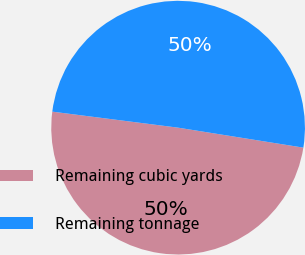Convert chart to OTSL. <chart><loc_0><loc_0><loc_500><loc_500><pie_chart><fcel>Remaining cubic yards<fcel>Remaining tonnage<nl><fcel>49.5%<fcel>50.5%<nl></chart> 